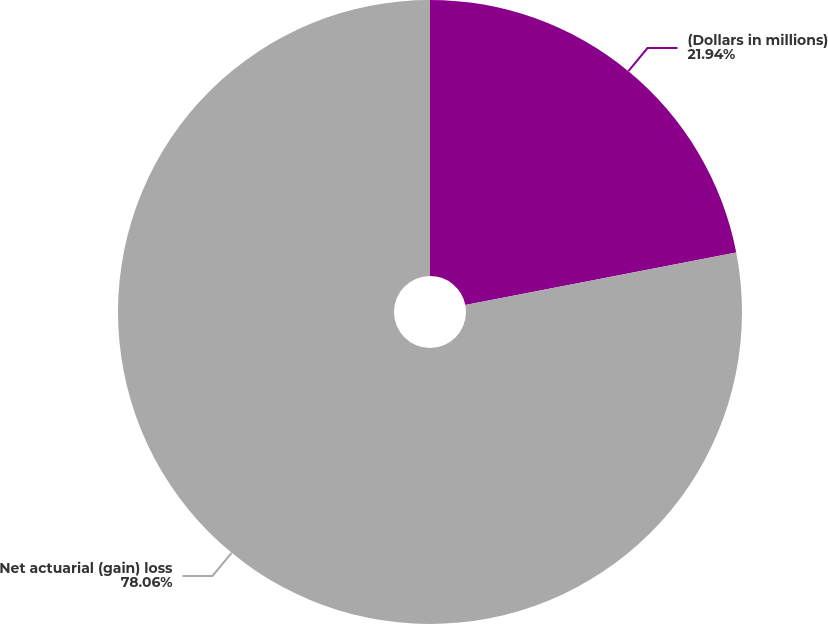Convert chart to OTSL. <chart><loc_0><loc_0><loc_500><loc_500><pie_chart><fcel>(Dollars in millions)<fcel>Net actuarial (gain) loss<nl><fcel>21.94%<fcel>78.06%<nl></chart> 